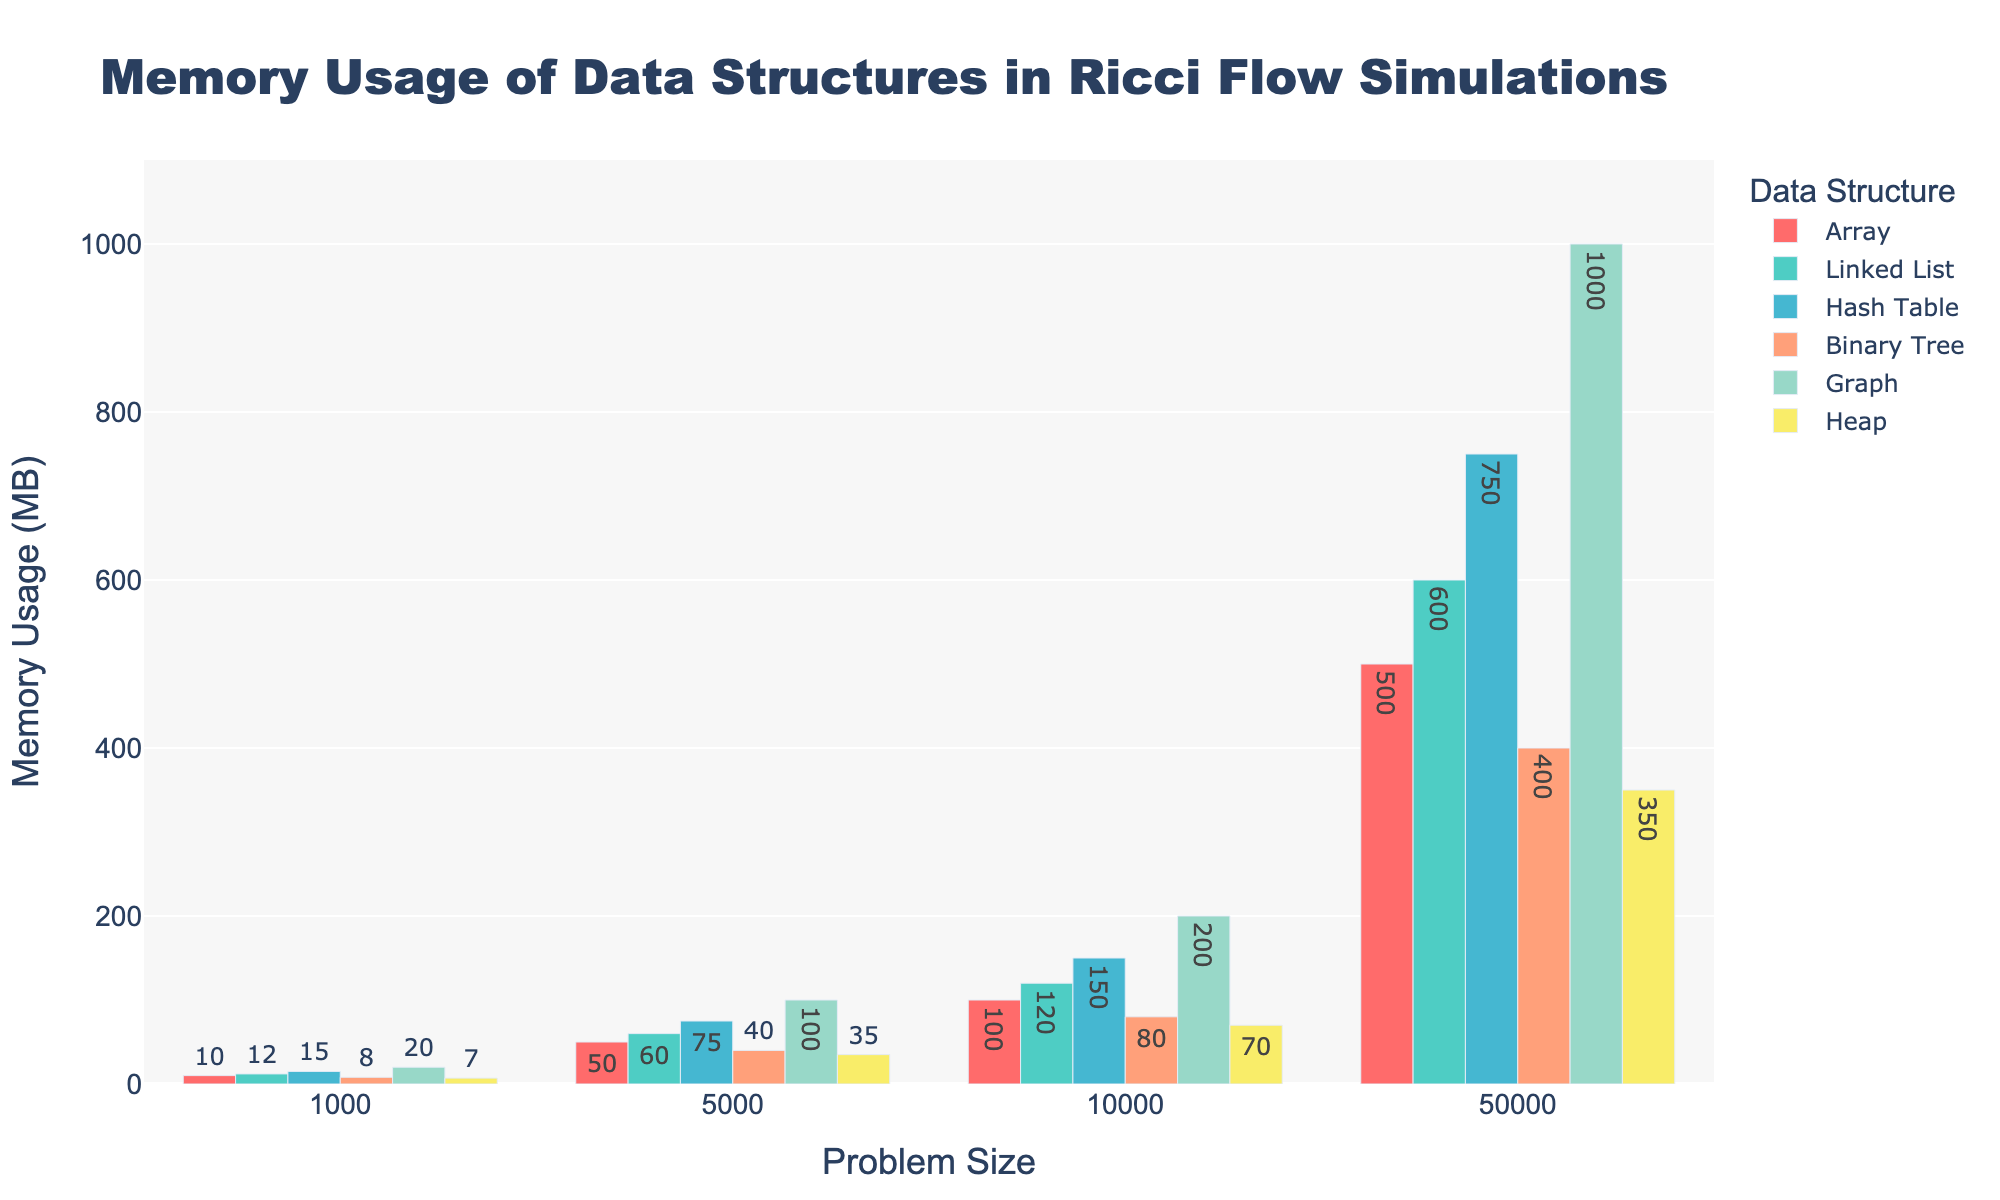What is the memory usage of the Hash Table at the largest problem size? Locate the bar representing Hash Table with the largest problem size, which is 50,000. The text label on this bar indicates the memory usage.
Answer: 750 MB Which data structure has the highest memory usage at problem size 10,000? At problem size 10,000, compare all the bars and identify the one with the highest value.
Answer: Graph By how much does the memory usage of a Binary Tree increase from problem size 1,000 to 50,000? Calculate the difference between the memory usage of the Binary Tree at 50,000 and at 1,000. For Binary Tree, values are 400 MB and 8 MB respectively.
Answer: 392 MB Which data structure uses the least memory at problem size 5,000? At problem size 5,000, find the bar with the shortest height, indicating the least memory usage.
Answer: Heap What is the combined memory usage of an Array and a Linked List at problem size 10,000? Add the memory usage of Array and Linked List at problem size 10,000. Array uses 100 MB and Linked List uses 120 MB.
Answer: 220 MB How does the memory usage of a Graph compare to a Heap at problem size 1,000? At problem size 1,000, compare the heights of the bars for the Graph and the Heap. The Graph is higher than the Heap.
Answer: Graph uses more What is the average memory usage of the Binary Tree across all problem sizes? Sum the memory usage of Binary Tree at all problem sizes (8 + 40 + 80 + 400) and divide by the number of problem sizes (4).
Answer: 132 MB Is the proportionate increase in memory usage from problem size 1,000 to 5,000 the same for Arrays and Linked Lists? Calculate the proportionate increase: for Arrays (50/10 = 5), for Linked Lists (60/12 = 5). Both have the same ratio.
Answer: Yes Which data structure shows the largest absolute increase in memory usage between any two consecutive problem sizes? Compare the increases in memory usage between consecutive problem sizes (1,000 to 5,000, 5,000 to 10,000, and 10,000 to 50,000) across all data structures. The largest increase is for Graphs from 10,000 to 50,000.
Answer: Graph 